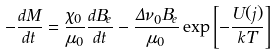Convert formula to latex. <formula><loc_0><loc_0><loc_500><loc_500>- \frac { d M } { d t } = \frac { \chi _ { 0 } } { \mu _ { 0 } } \frac { d B _ { e } } { d t } - \frac { \Delta \nu _ { 0 } B _ { e } } { \mu _ { 0 } } \exp \left [ - \frac { U ( j ) } { k T } \right ]</formula> 